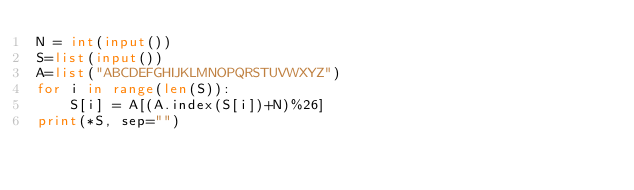Convert code to text. <code><loc_0><loc_0><loc_500><loc_500><_Python_>N = int(input())
S=list(input())
A=list("ABCDEFGHIJKLMNOPQRSTUVWXYZ")
for i in range(len(S)):
    S[i] = A[(A.index(S[i])+N)%26]
print(*S, sep="")</code> 